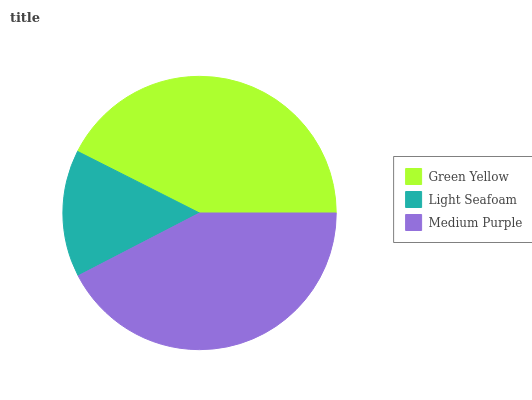Is Light Seafoam the minimum?
Answer yes or no. Yes. Is Green Yellow the maximum?
Answer yes or no. Yes. Is Medium Purple the minimum?
Answer yes or no. No. Is Medium Purple the maximum?
Answer yes or no. No. Is Medium Purple greater than Light Seafoam?
Answer yes or no. Yes. Is Light Seafoam less than Medium Purple?
Answer yes or no. Yes. Is Light Seafoam greater than Medium Purple?
Answer yes or no. No. Is Medium Purple less than Light Seafoam?
Answer yes or no. No. Is Medium Purple the high median?
Answer yes or no. Yes. Is Medium Purple the low median?
Answer yes or no. Yes. Is Green Yellow the high median?
Answer yes or no. No. Is Light Seafoam the low median?
Answer yes or no. No. 